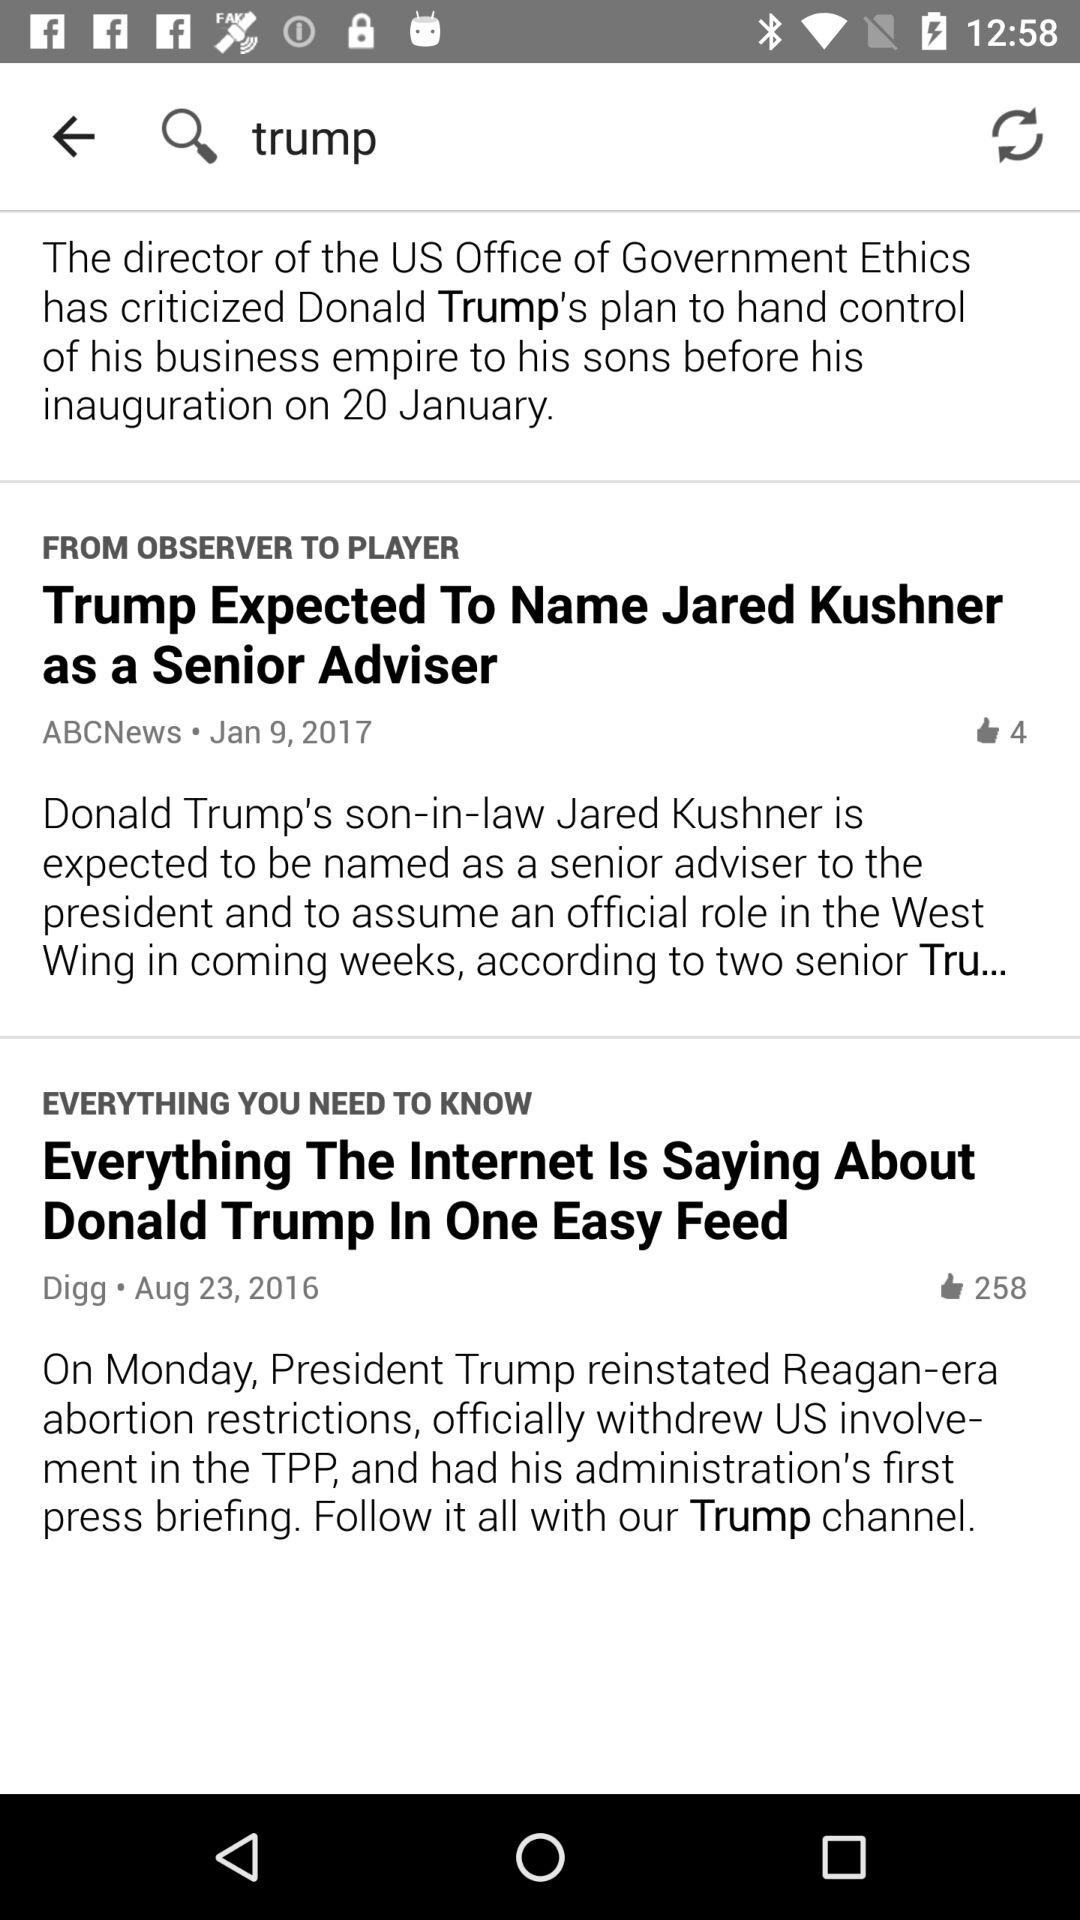How many likes are there on Digg? There are 258 likes on Digg. 